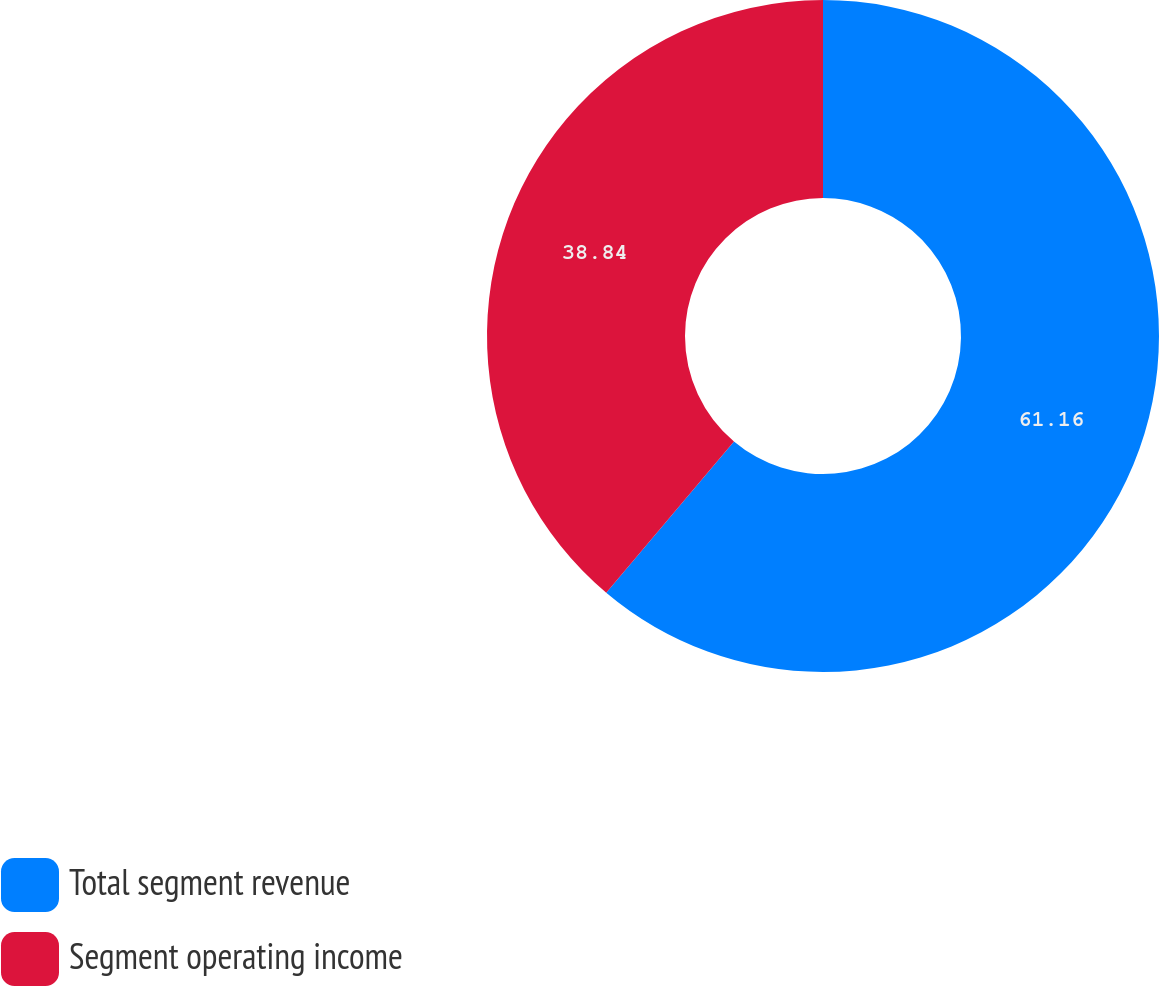Convert chart to OTSL. <chart><loc_0><loc_0><loc_500><loc_500><pie_chart><fcel>Total segment revenue<fcel>Segment operating income<nl><fcel>61.16%<fcel>38.84%<nl></chart> 